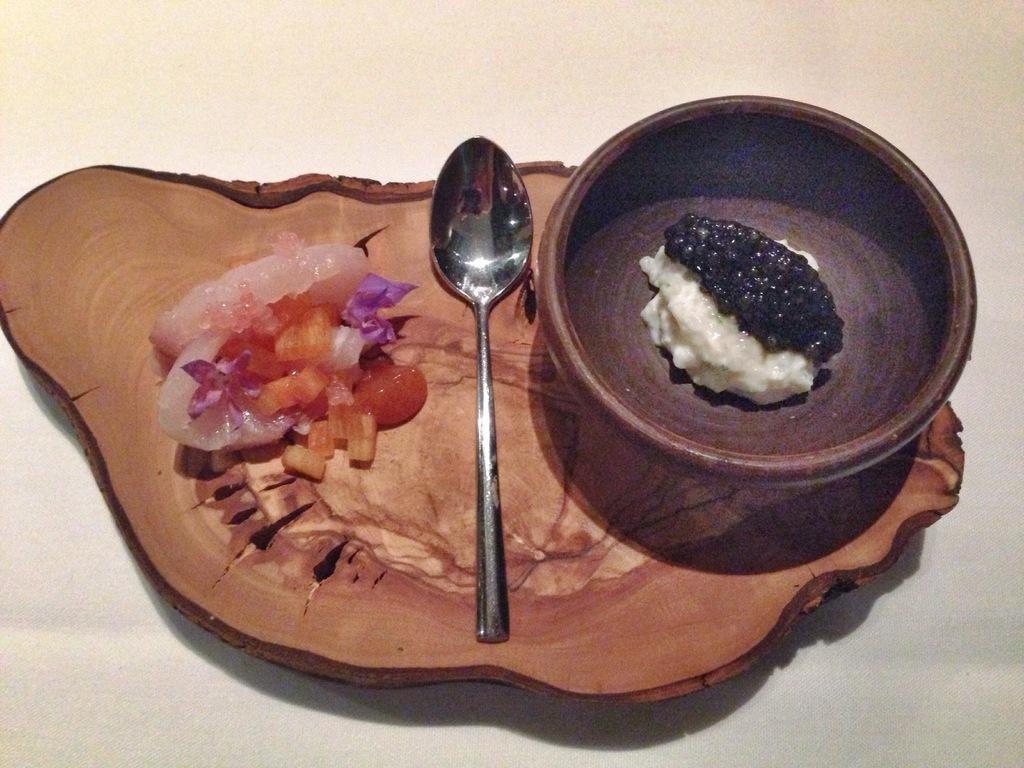Can you describe this image briefly? There is a wooden tray on the white surface. On that tree there is a salad, spoon and a bowl with some white and black food item. 